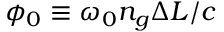<formula> <loc_0><loc_0><loc_500><loc_500>\phi _ { 0 } \equiv \omega _ { 0 } n _ { g } \Delta L / c</formula> 